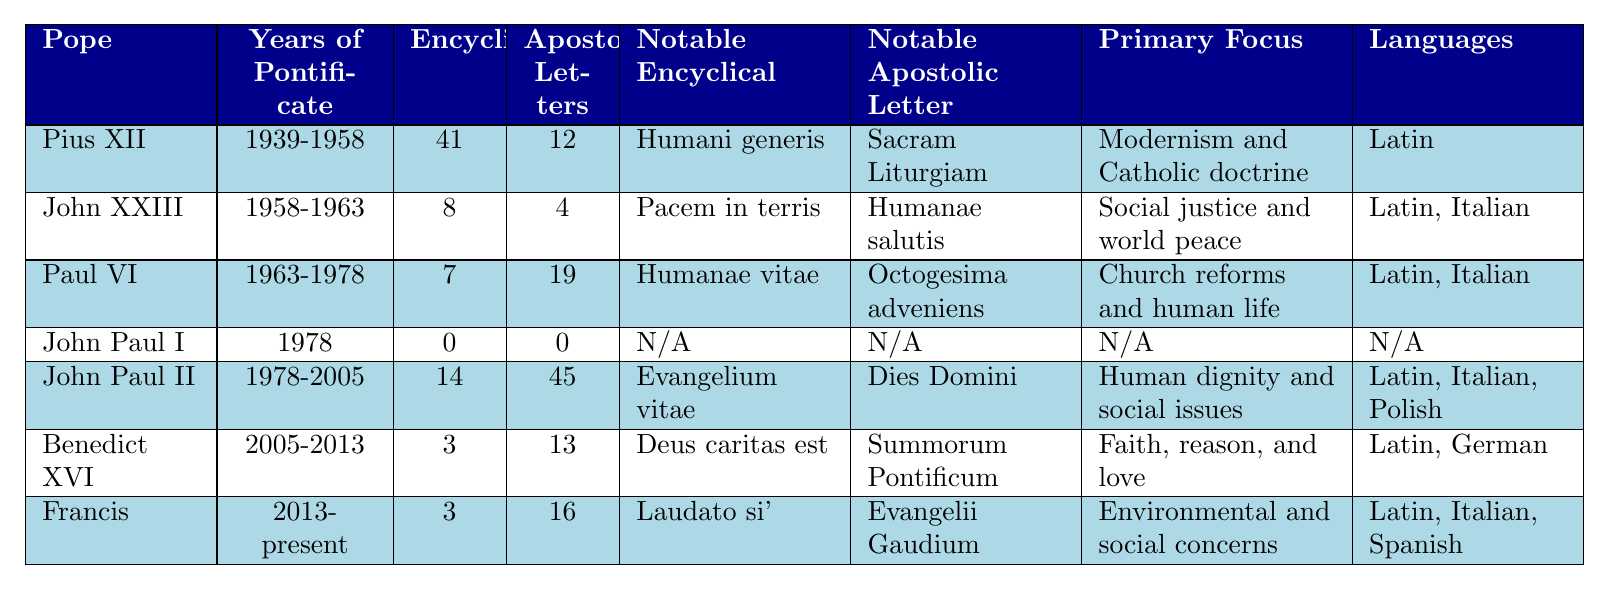What is the total number of encyclicals issued by all the Popes listed? To find the total number of encyclicals, add the number of encyclicals for each Pope: 41 + 8 + 7 + 0 + 14 + 3 + 3 = 76.
Answer: 76 Which Pope issued the highest number of apostolic letters? Looking at the table, John Paul II issued the highest number of apostolic letters with a total of 45.
Answer: John Paul II What is the primary focus of Benedict XVI's writings? By checking the table, Benedict XVI's primary focus is noted as "Faith, reason, and love."
Answer: Faith, reason, and love Did John Paul I issue any encyclicals or apostolic letters? According to the table, John Paul I has both encyclicals and apostolic letters listed as 0. Thus, he did not issue any of either.
Answer: No Which Pope's notable encyclical focuses on environmental and social concerns? The table indicates that Pope Francis has a notable encyclical, "Laudato si'," which focuses on environmental and social concerns.
Answer: Pope Francis How many more apostolic letters did Pope John XXIII issue than encyclicals? The difference can be calculated as follows: John XXIII issued 4 apostolic letters and 8 encyclicals. Therefore, 4 - 8 = -4, meaning he issued 4 fewer letters than encyclicals.
Answer: 4 fewer What languages did Pope John Paul II's notable encyclical get published in? According to the table, John Paul II's notable encyclical, "Evangelium vitae," was published in Latin, Italian, and Polish.
Answer: Latin, Italian, Polish Which Pope served for the shortest period and how many documents did he issue? From the table, John Paul I served only in 1978 and did not issue any encyclicals or apostolic letters, totaling 0 documents.
Answer: John Paul I, 0 documents Is it true that every Pope listed issued at least one encyclical? By reviewing the data, John Paul I did not issue any encyclicals. Thus, it is not true that every Pope issued at least one.
Answer: No What is the average number of encyclicals issued by the Popes listed? Add the number of encyclicals (41 + 8 + 7 + 0 + 14 + 3 + 3 = 76) and divide by the number of Popes (7). The average is 76 / 7 = approximately 10.86.
Answer: 10.86 Which Pope has the highest total of both encyclicals and apostolic letters combined? Calculate the total for each Pope: Pius XII: 53; John XXIII: 12; Paul VI: 26; John Paul I: 0; John Paul II: 59; Benedict XVI: 16; Francis: 19. The highest total is for John Paul II with 59.
Answer: John Paul II 